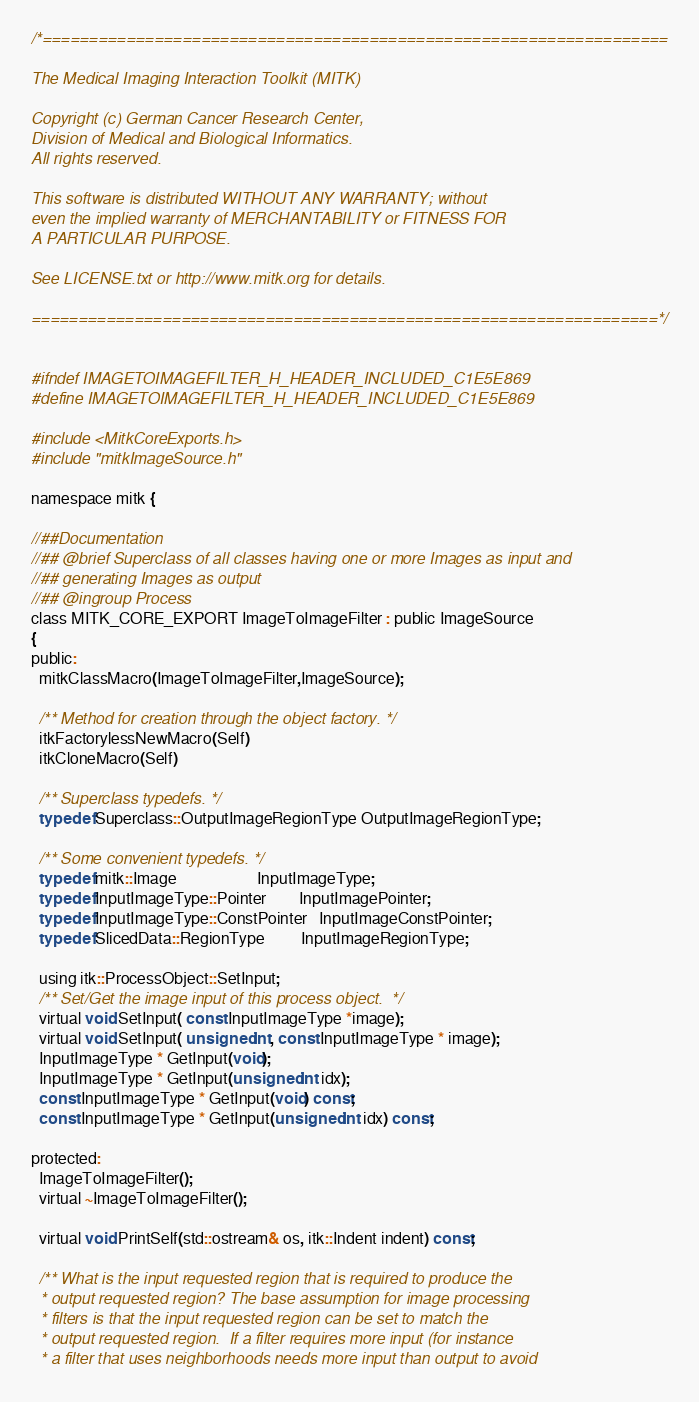<code> <loc_0><loc_0><loc_500><loc_500><_C_>/*===================================================================

The Medical Imaging Interaction Toolkit (MITK)

Copyright (c) German Cancer Research Center,
Division of Medical and Biological Informatics.
All rights reserved.

This software is distributed WITHOUT ANY WARRANTY; without
even the implied warranty of MERCHANTABILITY or FITNESS FOR
A PARTICULAR PURPOSE.

See LICENSE.txt or http://www.mitk.org for details.

===================================================================*/


#ifndef IMAGETOIMAGEFILTER_H_HEADER_INCLUDED_C1E5E869
#define IMAGETOIMAGEFILTER_H_HEADER_INCLUDED_C1E5E869

#include <MitkCoreExports.h>
#include "mitkImageSource.h"

namespace mitk {

//##Documentation
//## @brief Superclass of all classes having one or more Images as input and
//## generating Images as output
//## @ingroup Process
class MITK_CORE_EXPORT ImageToImageFilter : public ImageSource
{
public:
  mitkClassMacro(ImageToImageFilter,ImageSource);

  /** Method for creation through the object factory. */
  itkFactorylessNewMacro(Self)
  itkCloneMacro(Self)

  /** Superclass typedefs. */
  typedef Superclass::OutputImageRegionType OutputImageRegionType;

  /** Some convenient typedefs. */
  typedef mitk::Image                    InputImageType;
  typedef InputImageType::Pointer        InputImagePointer;
  typedef InputImageType::ConstPointer   InputImageConstPointer;
  typedef SlicedData::RegionType         InputImageRegionType;

  using itk::ProcessObject::SetInput;
  /** Set/Get the image input of this process object.  */
  virtual void SetInput( const InputImageType *image);
  virtual void SetInput( unsigned int, const InputImageType * image);
  InputImageType * GetInput(void);
  InputImageType * GetInput(unsigned int idx);
  const InputImageType * GetInput(void) const;
  const InputImageType * GetInput(unsigned int idx) const;

protected:
  ImageToImageFilter();
  virtual ~ImageToImageFilter();

  virtual void PrintSelf(std::ostream& os, itk::Indent indent) const;

  /** What is the input requested region that is required to produce the
  * output requested region? The base assumption for image processing
  * filters is that the input requested region can be set to match the
  * output requested region.  If a filter requires more input (for instance
  * a filter that uses neighborhoods needs more input than output to avoid</code> 